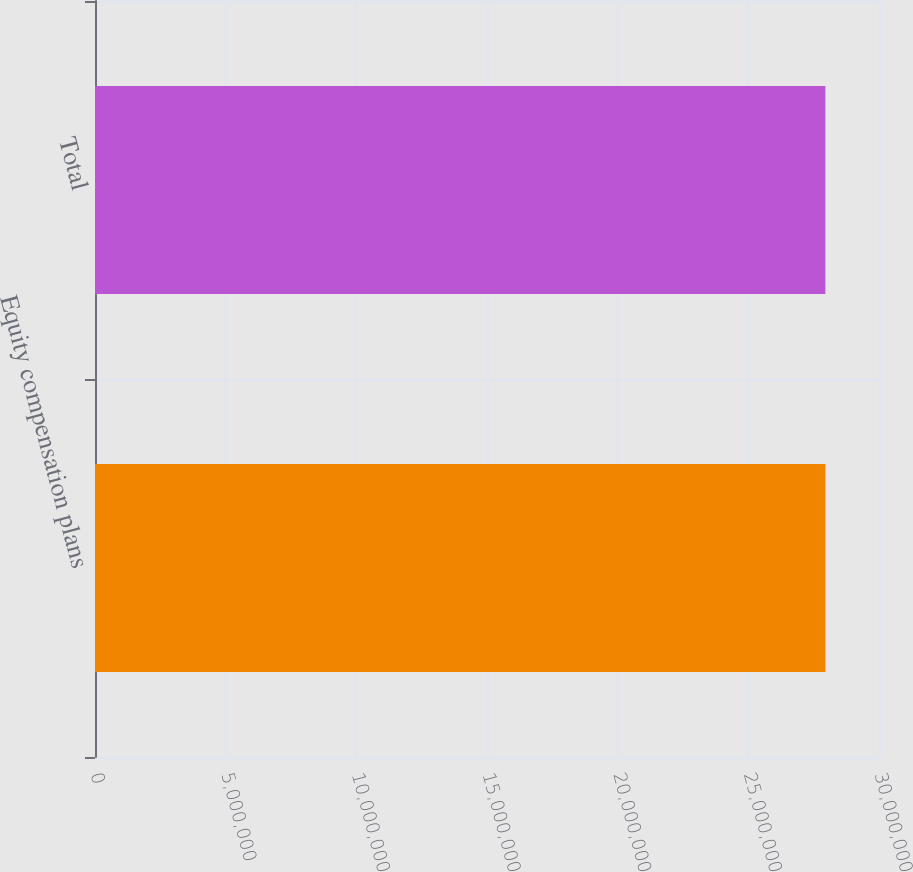Convert chart to OTSL. <chart><loc_0><loc_0><loc_500><loc_500><bar_chart><fcel>Equity compensation plans<fcel>Total<nl><fcel>2.79482e+07<fcel>2.79482e+07<nl></chart> 